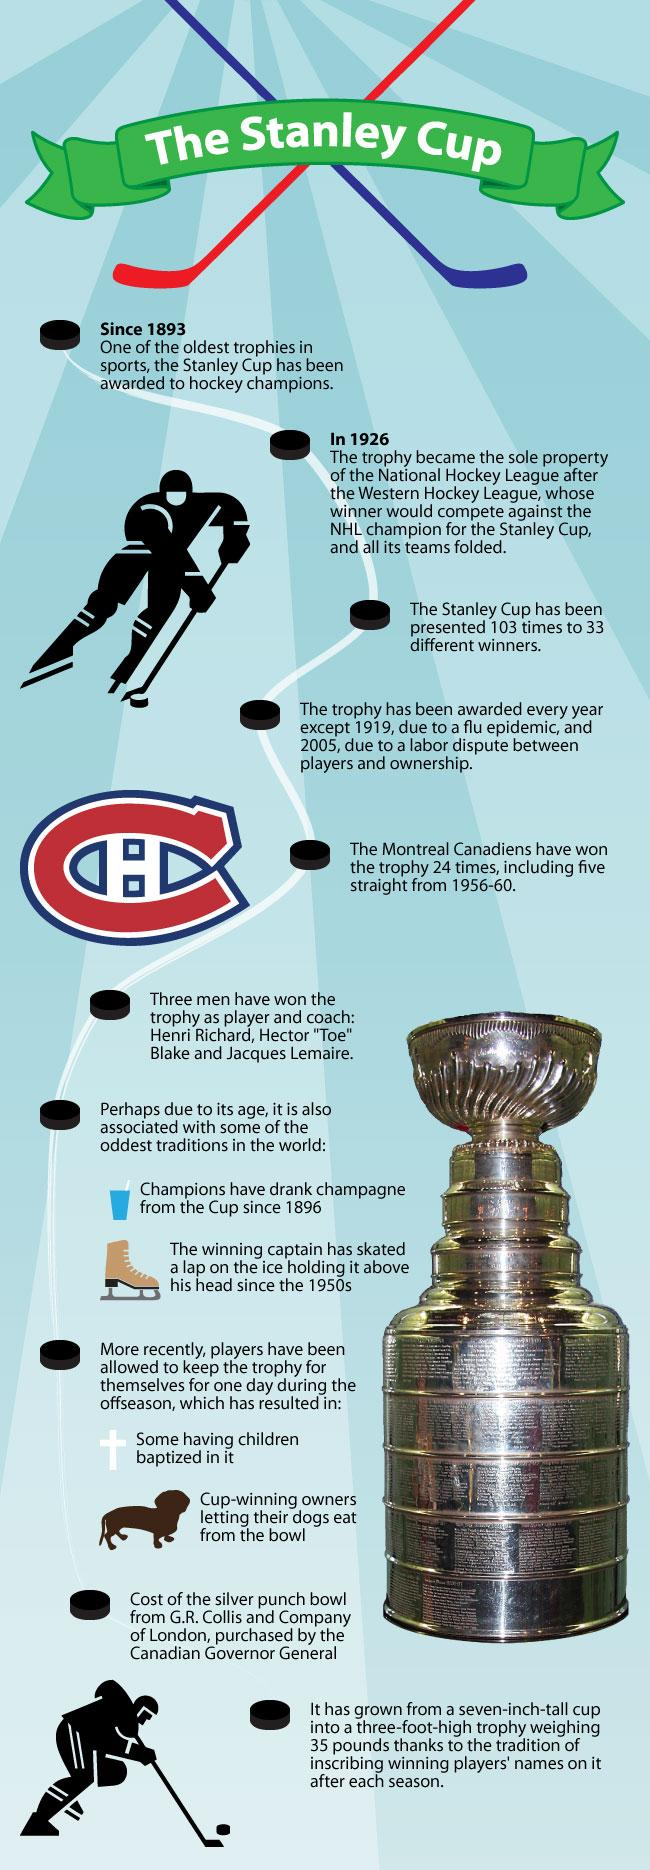Mention a couple of crucial points in this snapshot. There are two person images in this infographic. 